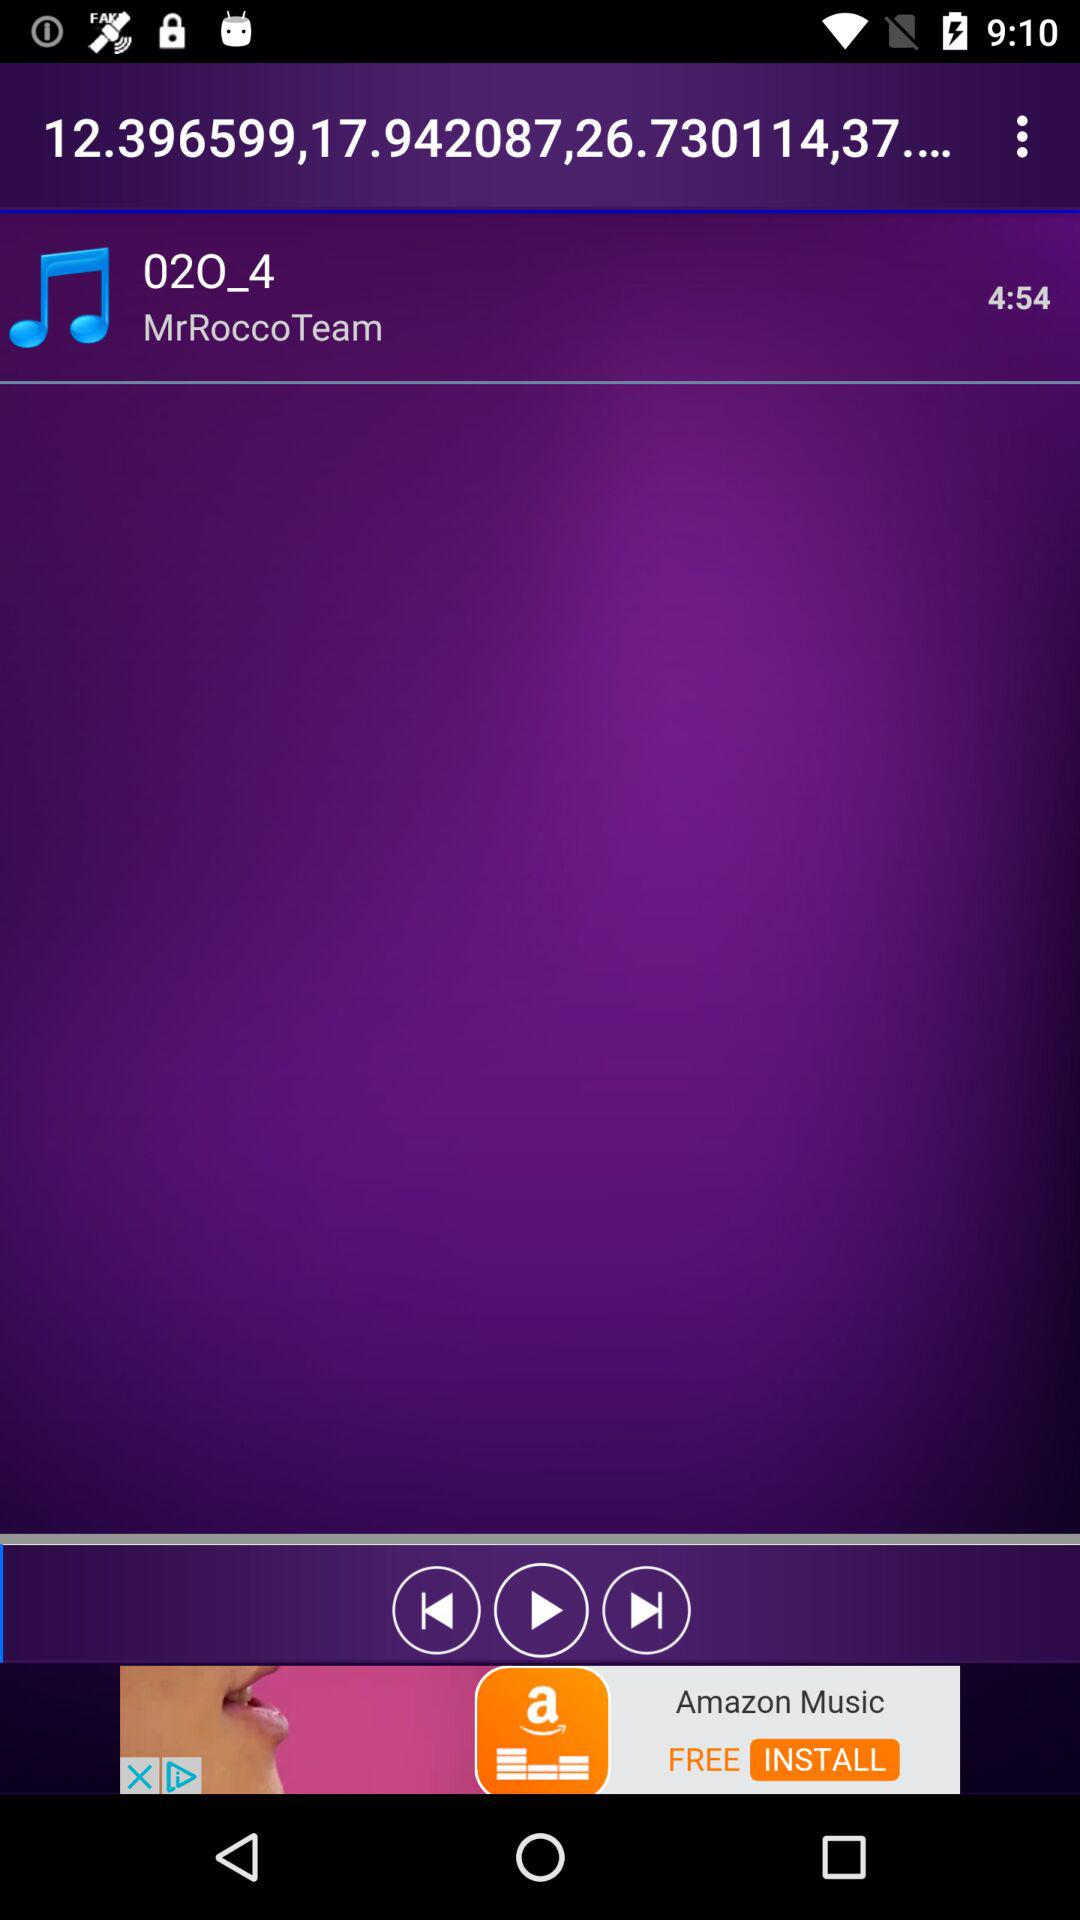What is the song duration? The song duration is 4 minutes 54 seconds. 